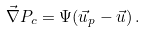Convert formula to latex. <formula><loc_0><loc_0><loc_500><loc_500>\vec { \nabla } P _ { c } = \Psi ( \vec { u } _ { p } - \vec { u } ) \, .</formula> 